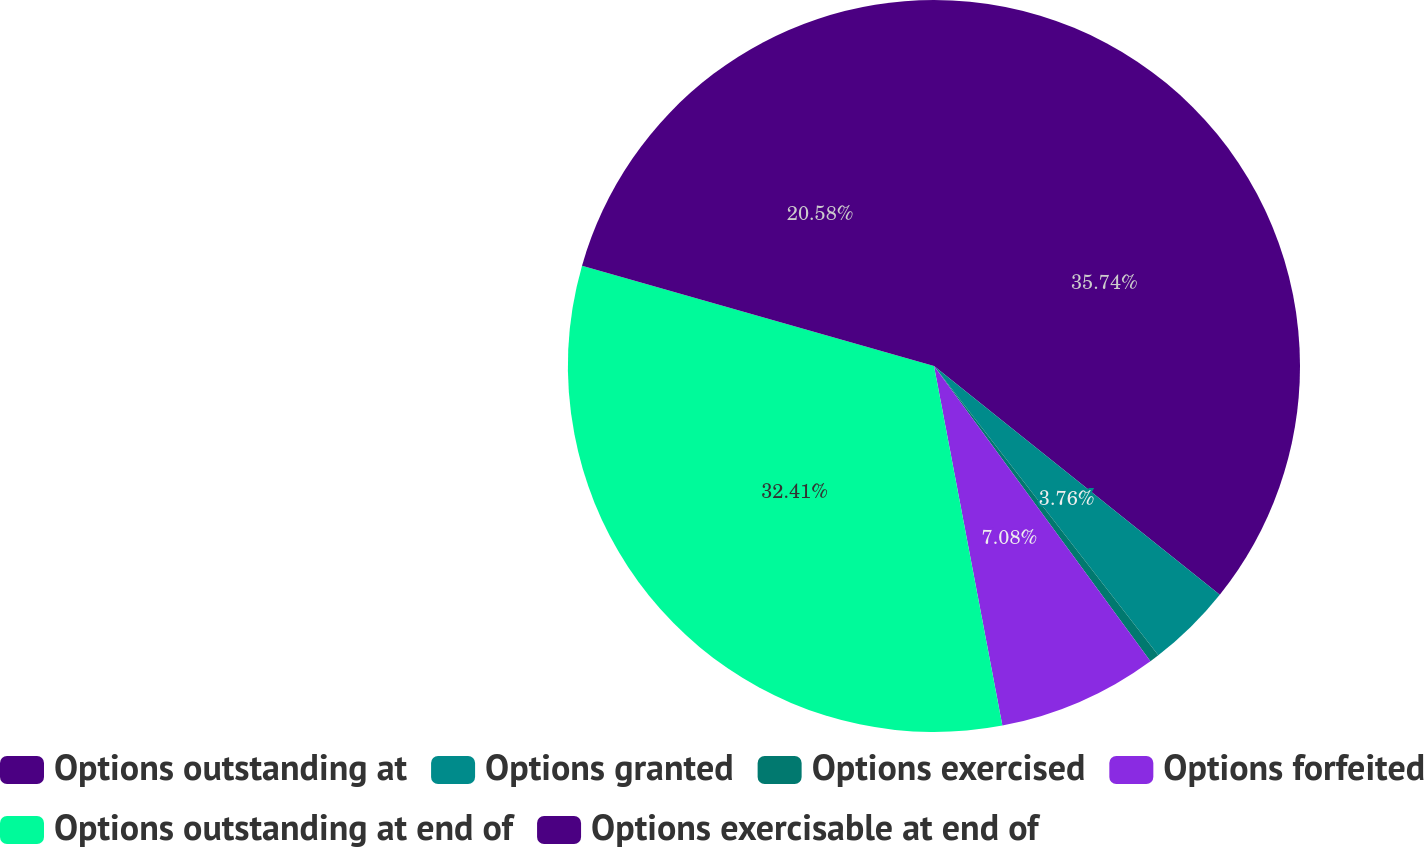Convert chart. <chart><loc_0><loc_0><loc_500><loc_500><pie_chart><fcel>Options outstanding at<fcel>Options granted<fcel>Options exercised<fcel>Options forfeited<fcel>Options outstanding at end of<fcel>Options exercisable at end of<nl><fcel>35.74%<fcel>3.76%<fcel>0.43%<fcel>7.08%<fcel>32.41%<fcel>20.58%<nl></chart> 